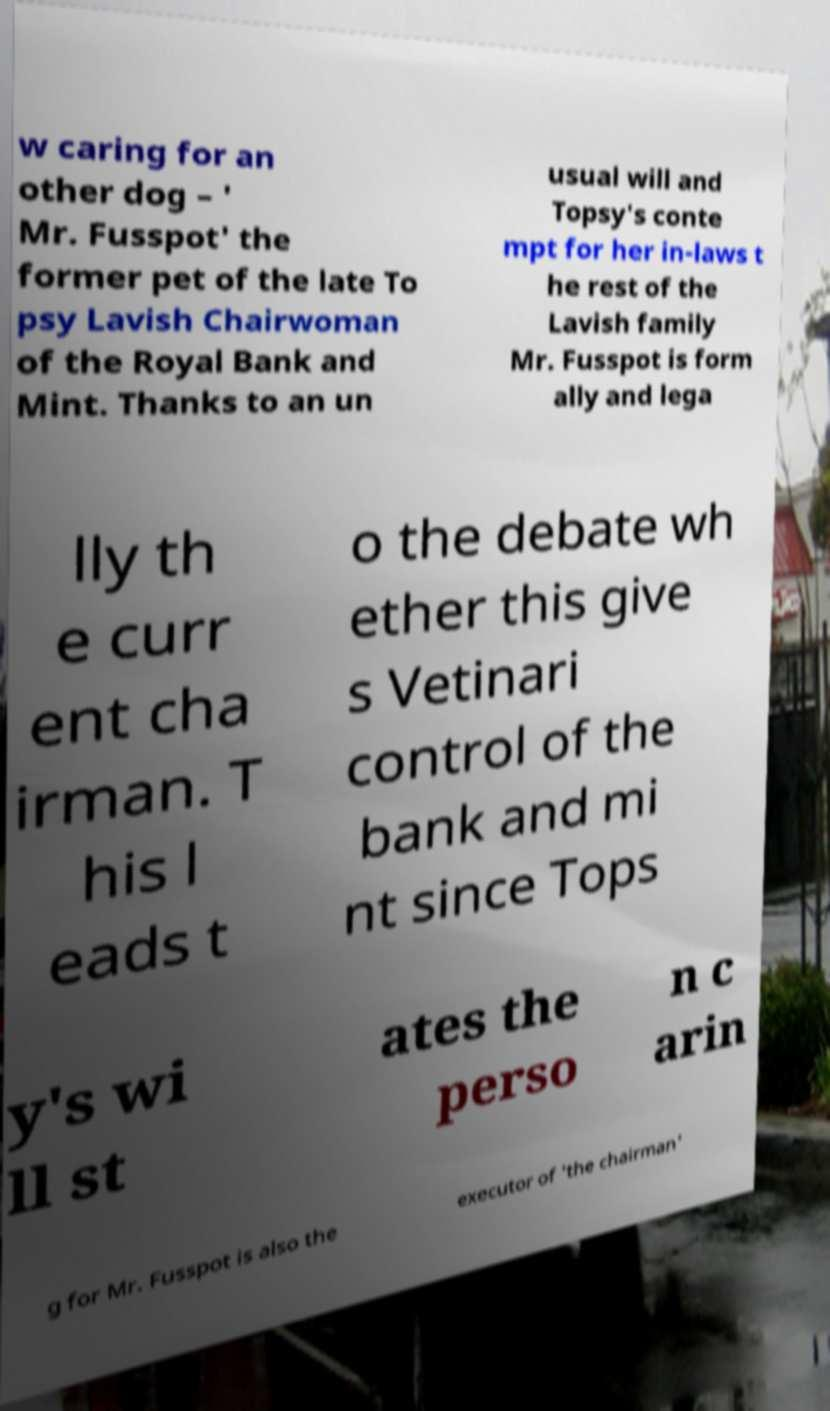Can you accurately transcribe the text from the provided image for me? w caring for an other dog – ' Mr. Fusspot' the former pet of the late To psy Lavish Chairwoman of the Royal Bank and Mint. Thanks to an un usual will and Topsy's conte mpt for her in-laws t he rest of the Lavish family Mr. Fusspot is form ally and lega lly th e curr ent cha irman. T his l eads t o the debate wh ether this give s Vetinari control of the bank and mi nt since Tops y's wi ll st ates the perso n c arin g for Mr. Fusspot is also the executor of 'the chairman' 